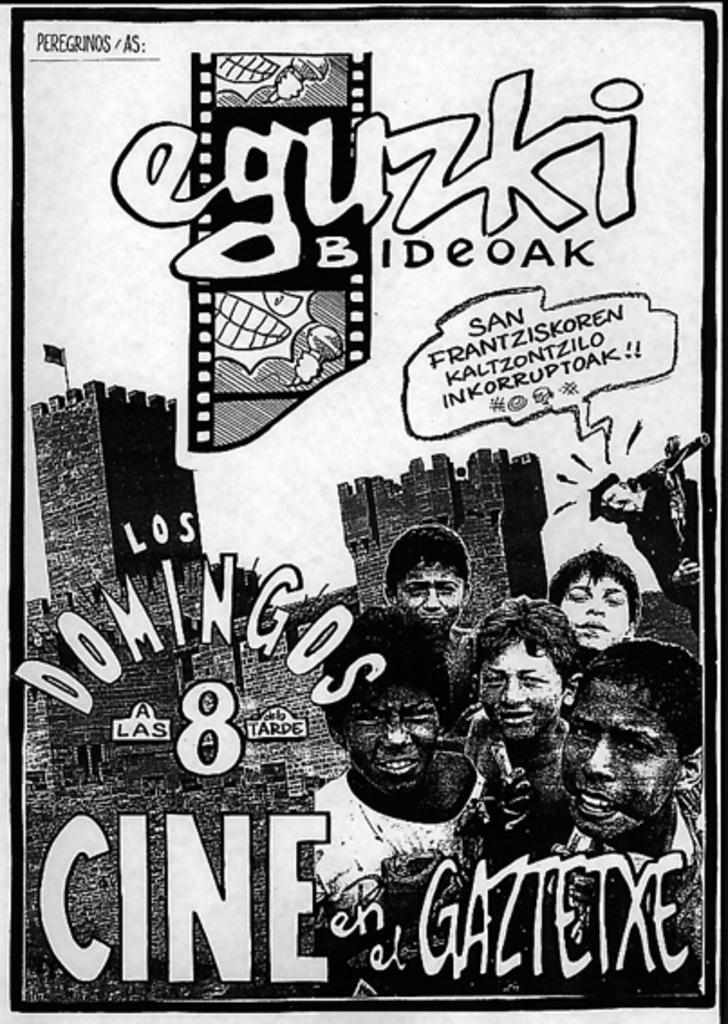In one or two sentences, can you explain what this image depicts? In the image we can see the poster in the poster we can see the black and white picture of the people and the text. 